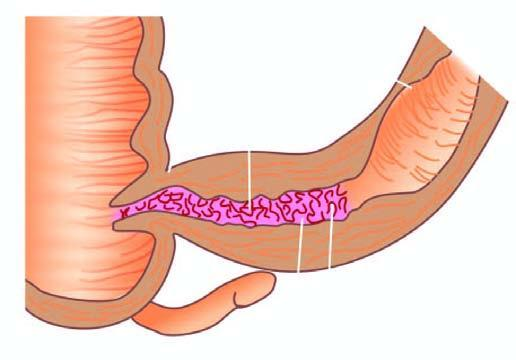what shows increased mesenteric fat, thickened wall and narrow lumen?
Answer the question using a single word or phrase. External surface 